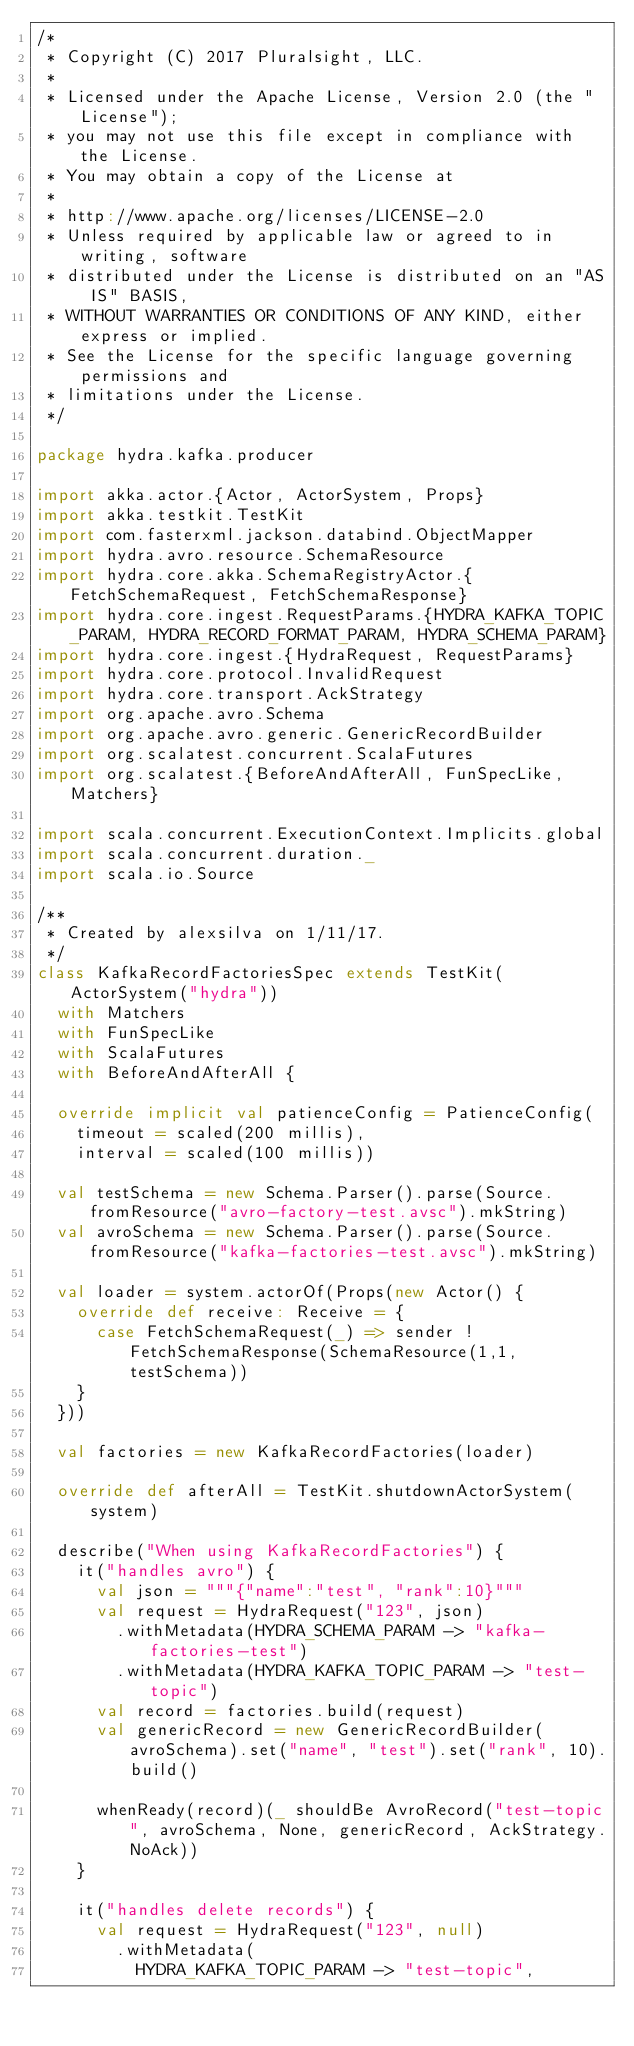Convert code to text. <code><loc_0><loc_0><loc_500><loc_500><_Scala_>/*
 * Copyright (C) 2017 Pluralsight, LLC.
 *
 * Licensed under the Apache License, Version 2.0 (the "License");
 * you may not use this file except in compliance with the License.
 * You may obtain a copy of the License at
 *
 * http://www.apache.org/licenses/LICENSE-2.0
 * Unless required by applicable law or agreed to in writing, software
 * distributed under the License is distributed on an "AS IS" BASIS,
 * WITHOUT WARRANTIES OR CONDITIONS OF ANY KIND, either express or implied.
 * See the License for the specific language governing permissions and
 * limitations under the License.
 */

package hydra.kafka.producer

import akka.actor.{Actor, ActorSystem, Props}
import akka.testkit.TestKit
import com.fasterxml.jackson.databind.ObjectMapper
import hydra.avro.resource.SchemaResource
import hydra.core.akka.SchemaRegistryActor.{FetchSchemaRequest, FetchSchemaResponse}
import hydra.core.ingest.RequestParams.{HYDRA_KAFKA_TOPIC_PARAM, HYDRA_RECORD_FORMAT_PARAM, HYDRA_SCHEMA_PARAM}
import hydra.core.ingest.{HydraRequest, RequestParams}
import hydra.core.protocol.InvalidRequest
import hydra.core.transport.AckStrategy
import org.apache.avro.Schema
import org.apache.avro.generic.GenericRecordBuilder
import org.scalatest.concurrent.ScalaFutures
import org.scalatest.{BeforeAndAfterAll, FunSpecLike, Matchers}

import scala.concurrent.ExecutionContext.Implicits.global
import scala.concurrent.duration._
import scala.io.Source

/**
 * Created by alexsilva on 1/11/17.
 */
class KafkaRecordFactoriesSpec extends TestKit(ActorSystem("hydra"))
  with Matchers
  with FunSpecLike
  with ScalaFutures
  with BeforeAndAfterAll {

  override implicit val patienceConfig = PatienceConfig(
    timeout = scaled(200 millis),
    interval = scaled(100 millis))

  val testSchema = new Schema.Parser().parse(Source.fromResource("avro-factory-test.avsc").mkString)
  val avroSchema = new Schema.Parser().parse(Source.fromResource("kafka-factories-test.avsc").mkString)

  val loader = system.actorOf(Props(new Actor() {
    override def receive: Receive = {
      case FetchSchemaRequest(_) => sender ! FetchSchemaResponse(SchemaResource(1,1,testSchema))
    }
  }))

  val factories = new KafkaRecordFactories(loader)

  override def afterAll = TestKit.shutdownActorSystem(system)

  describe("When using KafkaRecordFactories") {
    it("handles avro") {
      val json = """{"name":"test", "rank":10}"""
      val request = HydraRequest("123", json)
        .withMetadata(HYDRA_SCHEMA_PARAM -> "kafka-factories-test")
        .withMetadata(HYDRA_KAFKA_TOPIC_PARAM -> "test-topic")
      val record = factories.build(request)
      val genericRecord = new GenericRecordBuilder(avroSchema).set("name", "test").set("rank", 10).build()

      whenReady(record)(_ shouldBe AvroRecord("test-topic", avroSchema, None, genericRecord, AckStrategy.NoAck))
    }

    it("handles delete records") {
      val request = HydraRequest("123", null)
        .withMetadata(
          HYDRA_KAFKA_TOPIC_PARAM -> "test-topic",</code> 